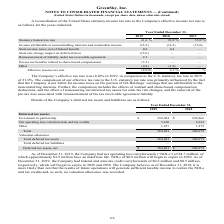According to Greensky's financial document, What was the Company's net operating loss carryforwards as of December 31, 2019? According to the financial document, 4.7 (in millions). The relevant text states: "had net operating loss carryforwards (“NOLs”) of $4.7 million, of which approximately $3.9 million have an indefinite life. NOLs of $0.8 million will beg..." Also, What was the company's investment in partnership in 2018? According to the financial document, 299,466 (in thousands). The relevant text states: "tax assets: Investment in partnership $ 358,024 $ 299,466 Net operating loss carryforwards and tax credits 5,160 5,634 Other 1,657 1,879 Total 364,841 306,97..." Also, Which years does the table provide information for the Company’s deferred tax assets and liabilities? The document shows two values: 2019 and 2018. From the document: "Year Ended December 31, 2019 2018 2017 Statutory federal tax rate 21.0 % 21.0 % 35.0 % Income attributable to noncontrolling int Year Ended December 3..." Also, How many years did Investment in partnership exceed $300,000 thousand? Based on the analysis, there are 1 instances. The counting process: 2019. Also, can you calculate: What was the change in the the Total deferred tax assets between 2018 and 2019? Based on the calculation: 364,841-306,979, the result is 57862 (in thousands). This is based on the information: "edits 5,160 5,634 Other 1,657 1,879 Total 364,841 306,979 Valuation allowance — — Total deferred tax assets 364,841 306,979 Total deferred tax liabilities — d tax credits 5,160 5,634 Other 1,657 1,879..." The key data points involved are: 306,979, 364,841. Also, can you calculate: What was the change in the Net operating loss carryforwards and tax credits between 2018 and 2019? To answer this question, I need to perform calculations using the financial data. The calculation is: (5,160-5,634)/5,634, which equals -8.41 (percentage). This is based on the information: "Net operating loss carryforwards and tax credits 5,160 5,634 Other 1,657 1,879 Total 364,841 306,979 Valuation allowance — — Total deferred tax assets 364 perating loss carryforwards and tax credits 5..." The key data points involved are: 5,160, 5,634. 